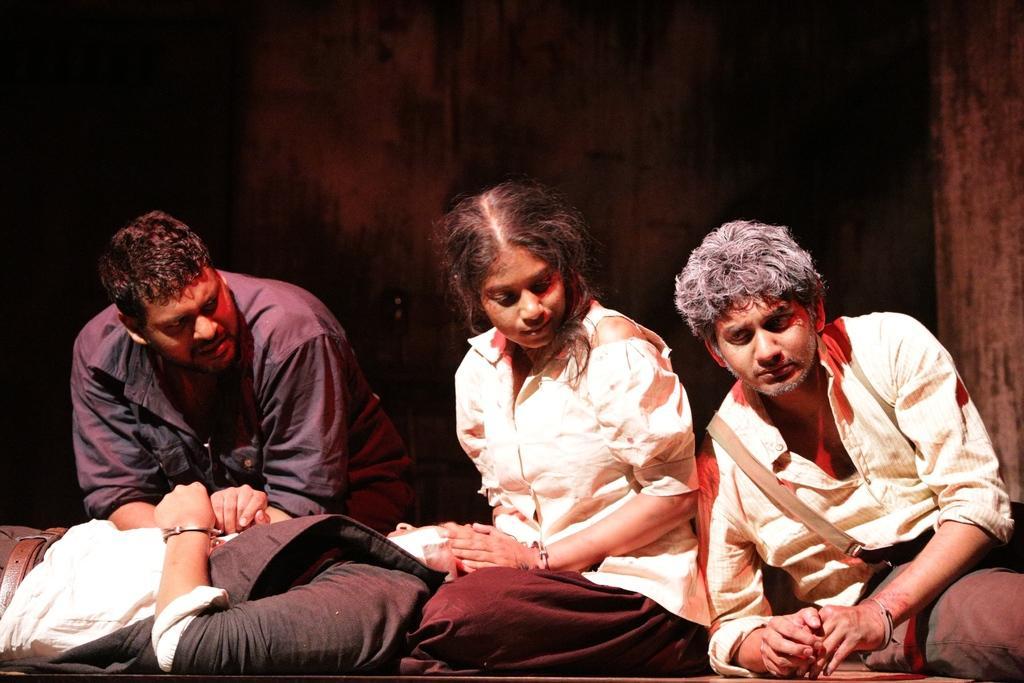Can you describe this image briefly? In this picture, we see three people are sitting on the floor. Out of them, two are men and one is a woman. In front of them, we see a man in white shirt and black jacket is sleeping on the floor. In the background, it is black in color. On the right side, it looks like a curtain. 